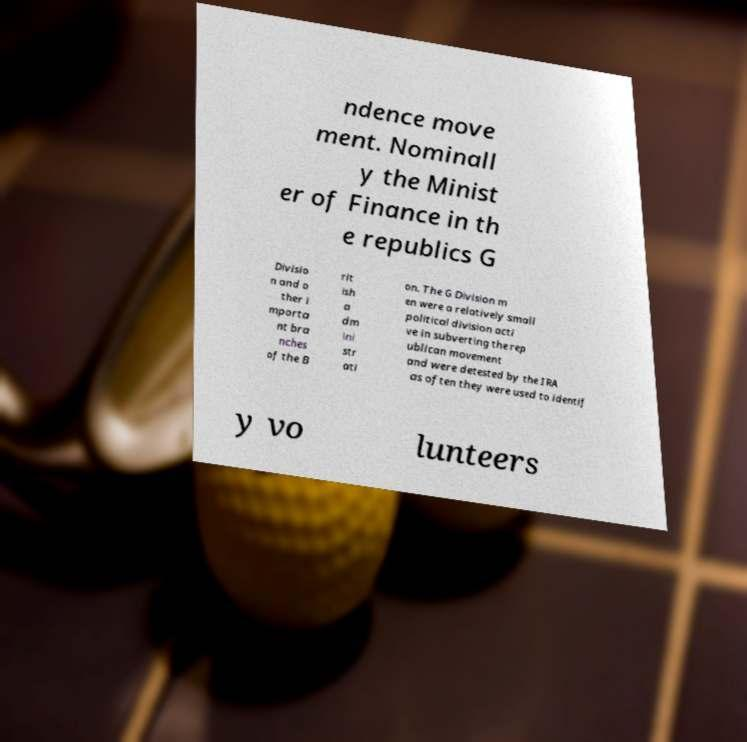Please read and relay the text visible in this image. What does it say? ndence move ment. Nominall y the Minist er of Finance in th e republics G Divisio n and o ther i mporta nt bra nches of the B rit ish a dm ini str ati on. The G Division m en were a relatively small political division acti ve in subverting the rep ublican movement and were detested by the IRA as often they were used to identif y vo lunteers 